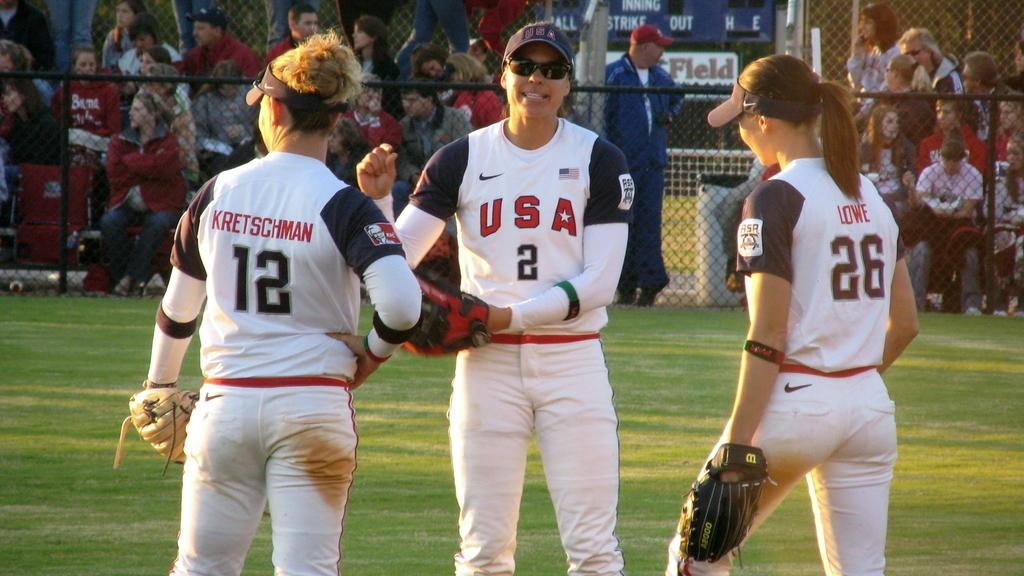What are the women in the image doing? The women are standing on the ground in the image. What are the women wearing? The women are wearing uniforms. What can be seen in the background of the image? There is a grill and spectators visible in the background of the image. What type of list can be seen in the hands of the women in the image? There is no list present in the image; the women are not holding anything. 